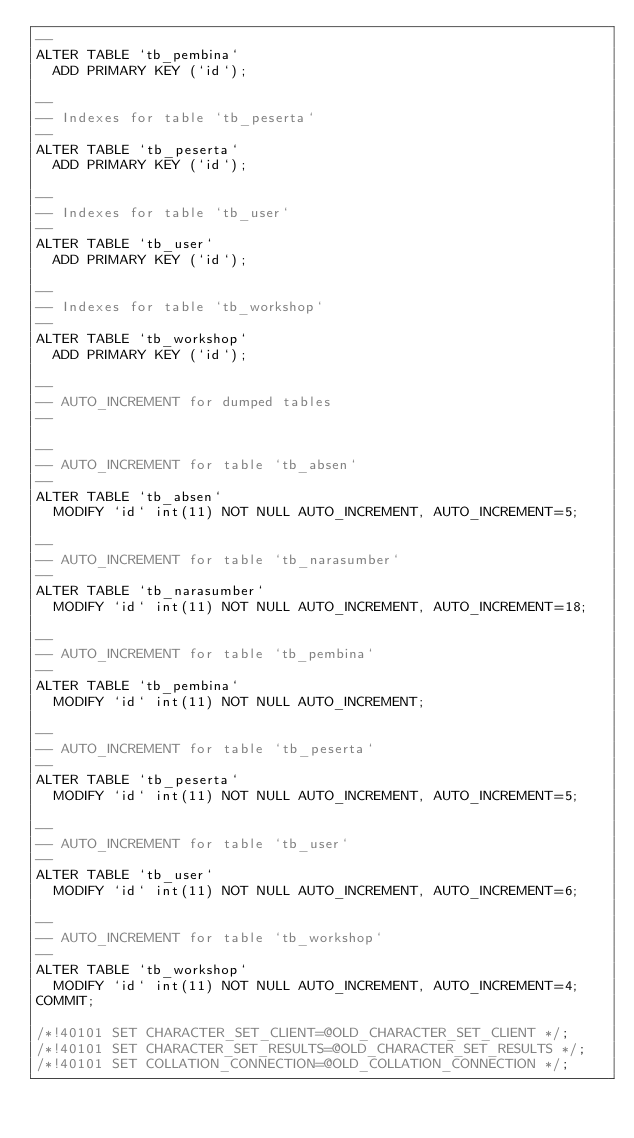Convert code to text. <code><loc_0><loc_0><loc_500><loc_500><_SQL_>--
ALTER TABLE `tb_pembina`
  ADD PRIMARY KEY (`id`);

--
-- Indexes for table `tb_peserta`
--
ALTER TABLE `tb_peserta`
  ADD PRIMARY KEY (`id`);

--
-- Indexes for table `tb_user`
--
ALTER TABLE `tb_user`
  ADD PRIMARY KEY (`id`);

--
-- Indexes for table `tb_workshop`
--
ALTER TABLE `tb_workshop`
  ADD PRIMARY KEY (`id`);

--
-- AUTO_INCREMENT for dumped tables
--

--
-- AUTO_INCREMENT for table `tb_absen`
--
ALTER TABLE `tb_absen`
  MODIFY `id` int(11) NOT NULL AUTO_INCREMENT, AUTO_INCREMENT=5;

--
-- AUTO_INCREMENT for table `tb_narasumber`
--
ALTER TABLE `tb_narasumber`
  MODIFY `id` int(11) NOT NULL AUTO_INCREMENT, AUTO_INCREMENT=18;

--
-- AUTO_INCREMENT for table `tb_pembina`
--
ALTER TABLE `tb_pembina`
  MODIFY `id` int(11) NOT NULL AUTO_INCREMENT;

--
-- AUTO_INCREMENT for table `tb_peserta`
--
ALTER TABLE `tb_peserta`
  MODIFY `id` int(11) NOT NULL AUTO_INCREMENT, AUTO_INCREMENT=5;

--
-- AUTO_INCREMENT for table `tb_user`
--
ALTER TABLE `tb_user`
  MODIFY `id` int(11) NOT NULL AUTO_INCREMENT, AUTO_INCREMENT=6;

--
-- AUTO_INCREMENT for table `tb_workshop`
--
ALTER TABLE `tb_workshop`
  MODIFY `id` int(11) NOT NULL AUTO_INCREMENT, AUTO_INCREMENT=4;
COMMIT;

/*!40101 SET CHARACTER_SET_CLIENT=@OLD_CHARACTER_SET_CLIENT */;
/*!40101 SET CHARACTER_SET_RESULTS=@OLD_CHARACTER_SET_RESULTS */;
/*!40101 SET COLLATION_CONNECTION=@OLD_COLLATION_CONNECTION */;
</code> 